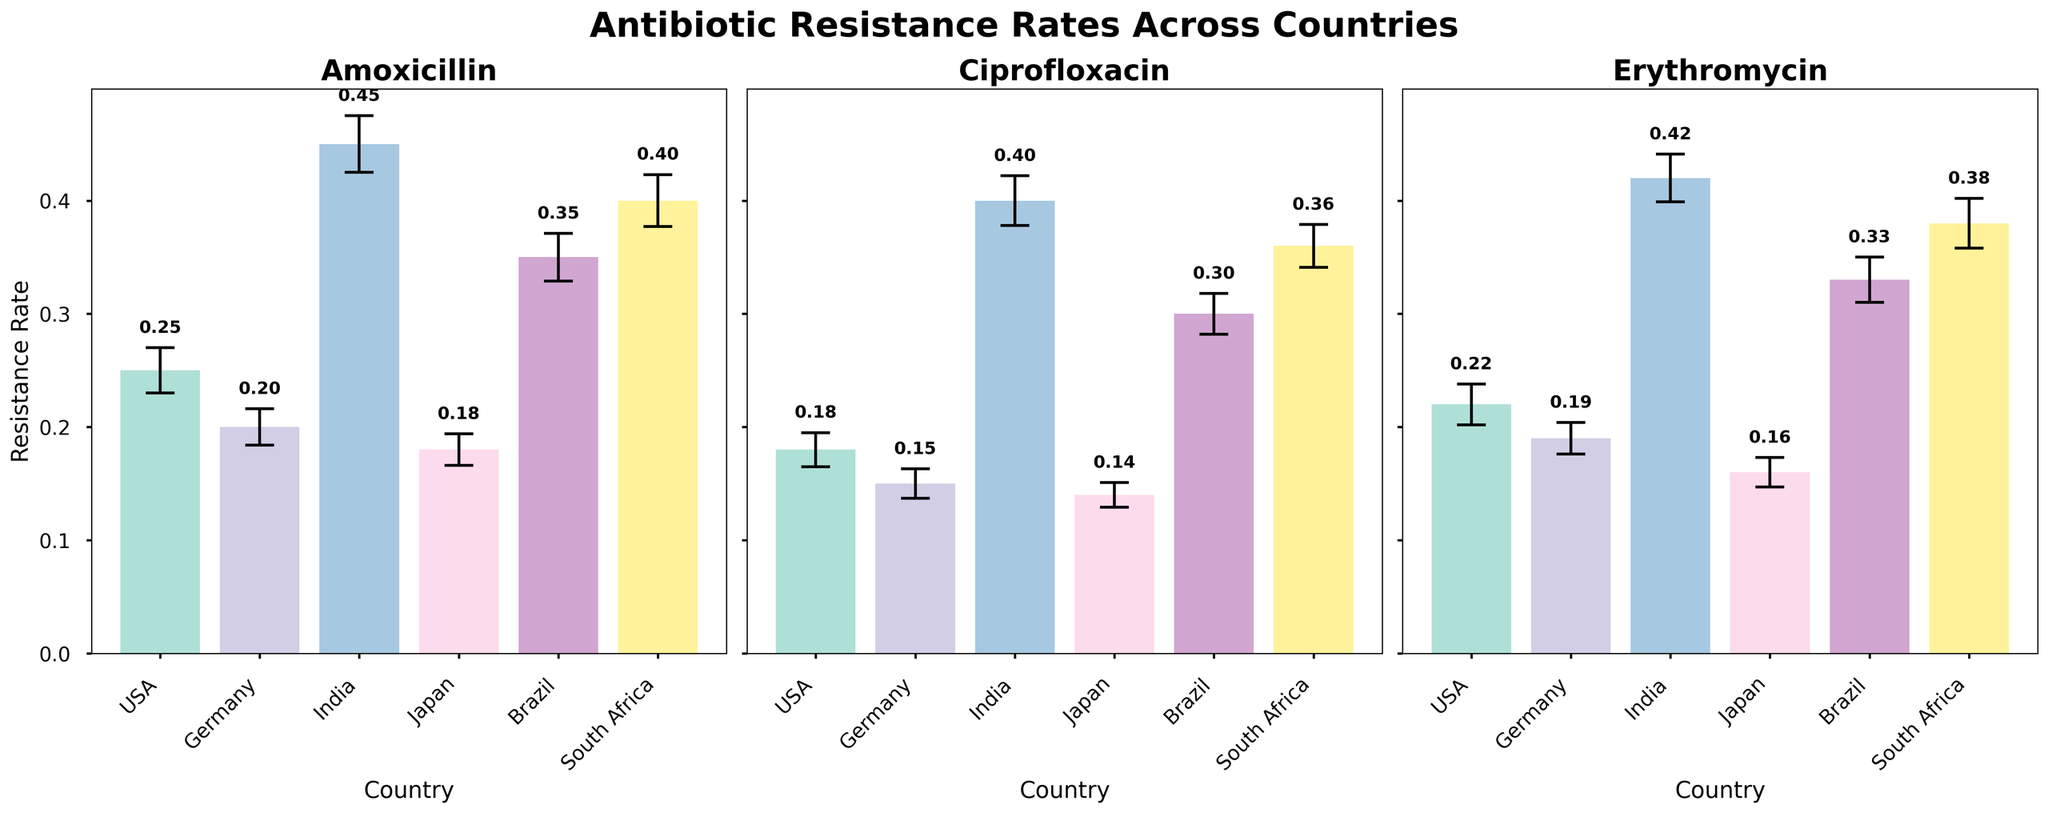What's the mean resistance rate of Amoxicillin in the USA? The figure has a subplot for Amoxicillin. The bar for the USA is labeled with its mean resistance rate.
Answer: 0.25 Which country has the highest mean resistance rate for Ciprofloxacin? In the Ciprofloxacin subplot, find the bar with the highest mean value. The annotated value for India is the highest.
Answer: India What is the difference in the mean resistance rate of Erythromycin between Germany and South Africa? In the Erythromycin subplot, find the mean resistance rates for Germany and South Africa and calculate the difference: 0.38 - 0.19.
Answer: 0.19 Which antibiotic shows the lowest mean resistance rate in Japan? In the subplot for each antibiotic, find the annotated mean resistance rates for Japan and identify the lowest value: Ciprofloxacin has the lowest mean resistance rate in Japan (0.14).
Answer: Ciprofloxacin What is the total mean resistance rate for Amoxicillin across all countries? Sum the mean resistance rates for Amoxicillin from each country: 0.25 (USA) + 0.20 (Germany) + 0.45 (India) + 0.18 (Japan) + 0.35 (Brazil) + 0.40 (South Africa) = 1.83.
Answer: 1.83 Which country has the smallest standard error for any antibiotic, and what is its value? Find the lowest standard error in the figure by comparing the error bars. Japan for Ciprofloxacin shows the smallest standard error (0.011).
Answer: Japan, 0.011 How much greater is the mean resistance rate of Erythromycin in Brazil compared to Japan? In the Erythromycin subplot, find the mean resistance rates for Brazil and Japan and calculate the difference: 0.33 - 0.16.
Answer: 0.17 What is the average mean resistance rate for Ciprofloxacin across all countries? Sum the mean resistance rates for Ciprofloxacin and divide by the number of countries: (0.18 + 0.15 + 0.40 + 0.14 + 0.30 + 0.36) / 6 = 1.53 / 6.
Answer: 0.255 